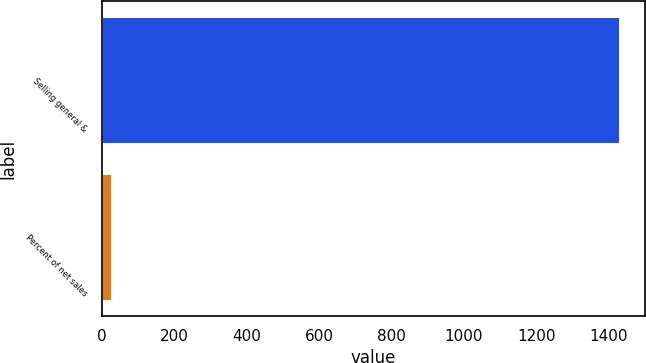Convert chart. <chart><loc_0><loc_0><loc_500><loc_500><bar_chart><fcel>Selling general &<fcel>Percent of net sales<nl><fcel>1429.5<fcel>26.4<nl></chart> 